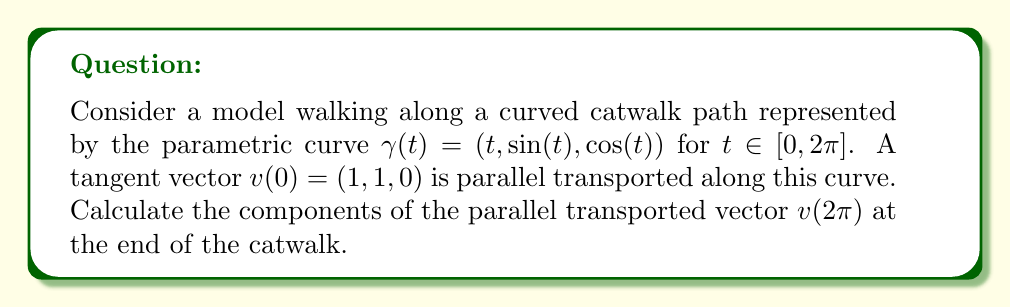Can you answer this question? To solve this problem, we'll follow these steps:

1) First, we need to calculate the tangent vector $T(t)$ to the curve:
   $$T(t) = \gamma'(t) = (1, \cos(t), -\sin(t))$$

2) Next, we calculate the normal vector $N(t)$:
   $$N(t) = \frac{T'(t)}{|T'(t)|} = (0, -\sin(t), -\cos(t))$$

3) The binormal vector $B(t)$ is given by the cross product of $T(t)$ and $N(t)$:
   $$B(t) = T(t) \times N(t) = (-1, -\sin(t), \cos(t))$$

4) Now we can form the Frenet frame $[T(t), N(t), B(t)]$.

5) The parallel transport equation in the Frenet frame is:
   $$\frac{dv}{dt} + \kappa(t)[v \cdot N(t)]T(t) - \kappa(t)[v \cdot T(t)]N(t) + \tau(t)[v \cdot N(t)]B(t) = 0$$
   where $\kappa(t)$ is the curvature and $\tau(t)$ is the torsion.

6) For this curve, $\kappa(t) = 1$ and $\tau(t) = 0$.

7) Let $v(t) = (a(t), b(t), c(t))$ in the Frenet frame. Substituting into the parallel transport equation:
   $$\frac{d}{dt}(a,b,c) + b(1,0,0) - a(0,1,0) = (0,0,0)$$

8) This gives us the system of differential equations:
   $$\frac{da}{dt} = -b, \quad \frac{db}{dt} = a, \quad \frac{dc}{dt} = 0$$

9) The solutions to these equations are:
   $$a(t) = A\cos(t) + B\sin(t), \quad b(t) = -A\sin(t) + B\cos(t), \quad c(t) = C$$
   where $A$, $B$, and $C$ are constants determined by the initial conditions.

10) Given $v(0) = (1,1,0)$ in the global frame, we need to convert this to the Frenet frame at $t=0$:
    $$v(0) = (1,1,0) = 1T(0) + 1N(0) + 0B(0) = (1,1,0)$$

11) This gives us $A=1$, $B=1$, and $C=0$.

12) Therefore, in the Frenet frame:
    $$v(2\pi) = (\cos(2\pi) + \sin(2\pi), -\sin(2\pi) + \cos(2\pi), 0) = (1, 1, 0)$$

13) To convert back to the global frame, we use the Frenet frame at $t=2\pi$:
    $$v(2\pi) = 1T(2\pi) + 1N(2\pi) + 0B(2\pi) = (1, 1, 0)$$

Therefore, the parallel transported vector at the end of the catwalk is $(1, 1, 0)$.
Answer: $(1, 1, 0)$ 